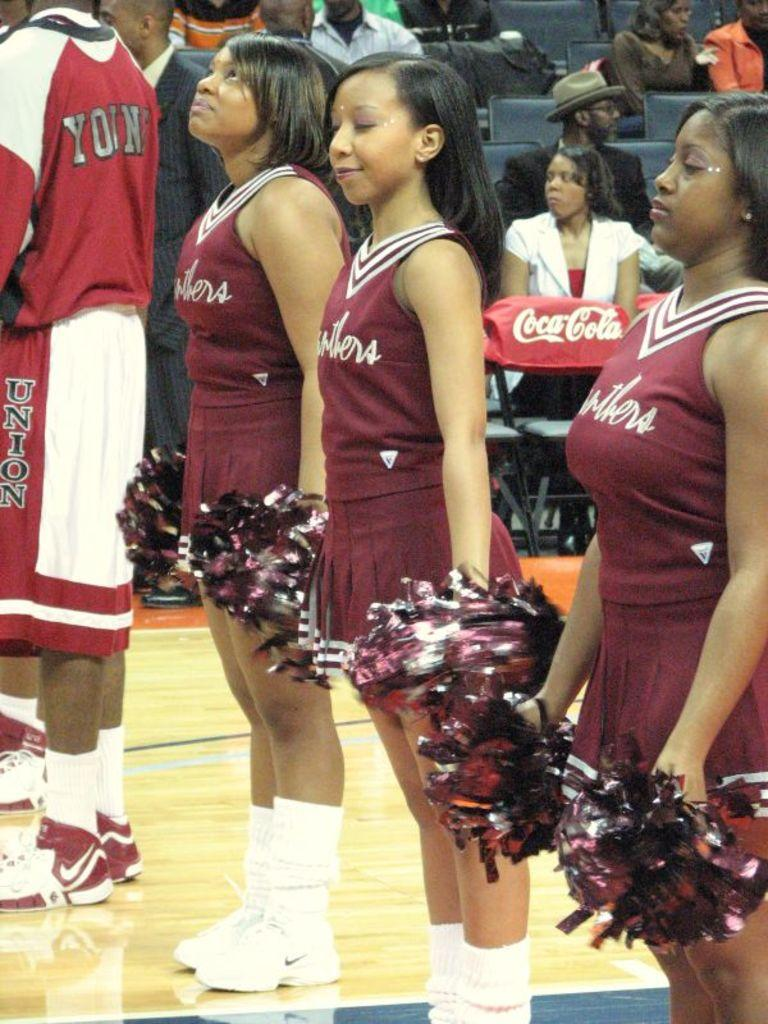Provide a one-sentence caption for the provided image. A player whose shorts say Union on the side stands near a group of cheerleaders. 